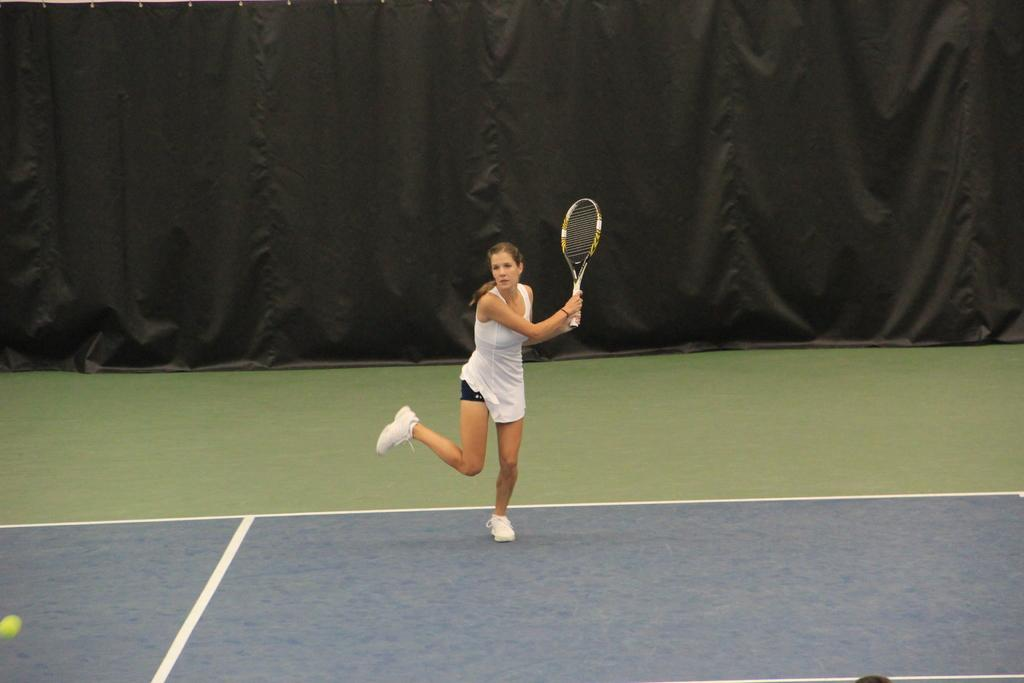Where is the image taken? The image is taken in a tennis court. What is the woman in the image doing? The woman is playing tennis. What color is the dress the woman is wearing? The woman is wearing a white dress. What type of shoes is the woman wearing? The woman is wearing white shoes. What can be seen in the background of the image? There is a black cloth in the background. How many pizzas are being served to the group in the image? There is no group or pizzas present in the image; it features a woman playing tennis in a tennis court. 